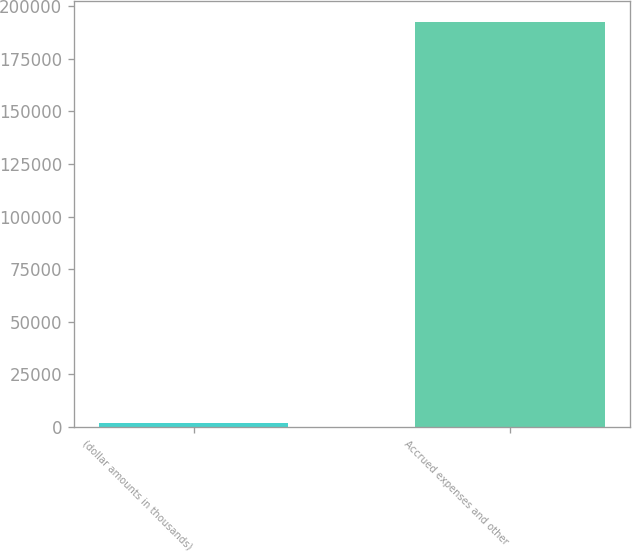Convert chart. <chart><loc_0><loc_0><loc_500><loc_500><bar_chart><fcel>(dollar amounts in thousands)<fcel>Accrued expenses and other<nl><fcel>2015<fcel>192734<nl></chart> 